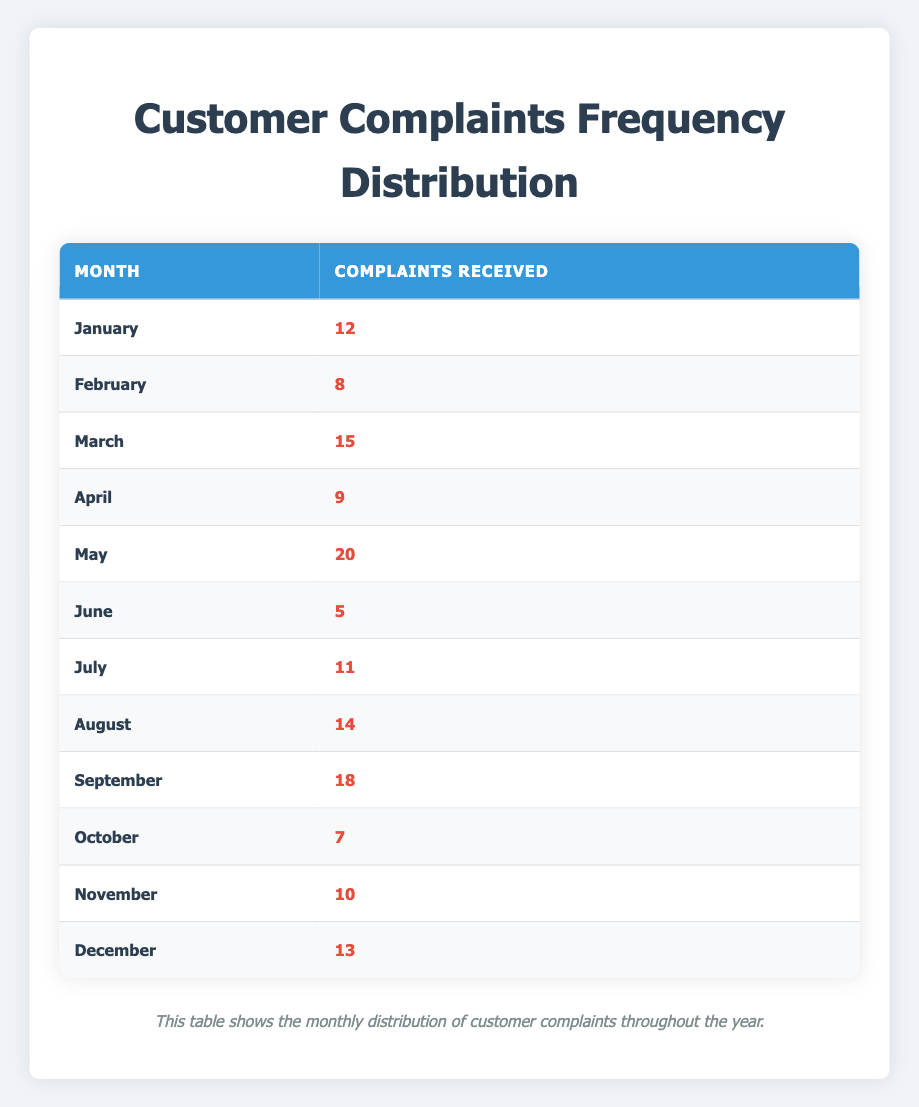What month had the highest number of complaints? Looking at the complaints received each month, May shows the highest number at 20 complaints.
Answer: May What is the total number of complaints received from January to March? The complaints for January, February, and March are 12, 8, and 15 respectively. Summing these gives: 12 + 8 + 15 = 35.
Answer: 35 Was the number of complaints received in June greater than that in October? June had 5 complaints while October had 7. Since 5 is not greater than 7, the answer is no.
Answer: No What is the average number of complaints received per month? To find the average, sum all complaints (12 + 8 + 15 + 9 + 20 + 5 + 11 + 14 + 18 + 7 + 10 + 13 =  152) and divide by the number of months (12): 152/12 = 12.67.
Answer: 12.67 In which month did the number of complaints drop below 10? The months with complaints below 10 are February with 8 and June with 5.
Answer: February and June What is the difference between the highest and lowest number of complaints received in a month? The highest number of complaints is in May (20 complaints) and the lowest is in June (5 complaints). The difference is 20 - 5 = 15.
Answer: 15 How many months received more than 10 complaints? The months with more than 10 complaints are January, March, May, July, August, September, November, and December—totaling 8 months.
Answer: 8 Did the number of complaints received in September surpass those received in November? September had 18 complaints and November had 10. Since 18 is greater than 10, the answer is yes.
Answer: Yes What is the median number of complaints received across all months? Arranging the complaints in order (5, 7, 8, 9, 10, 11, 12, 13, 14, 15, 18, 20), the median falls between the 6th and 7th entries. ((11 + 12) / 2) = 11.5.
Answer: 11.5 